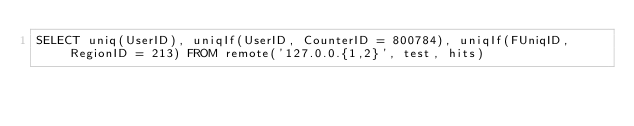Convert code to text. <code><loc_0><loc_0><loc_500><loc_500><_SQL_>SELECT uniq(UserID), uniqIf(UserID, CounterID = 800784), uniqIf(FUniqID, RegionID = 213) FROM remote('127.0.0.{1,2}', test, hits)
</code> 